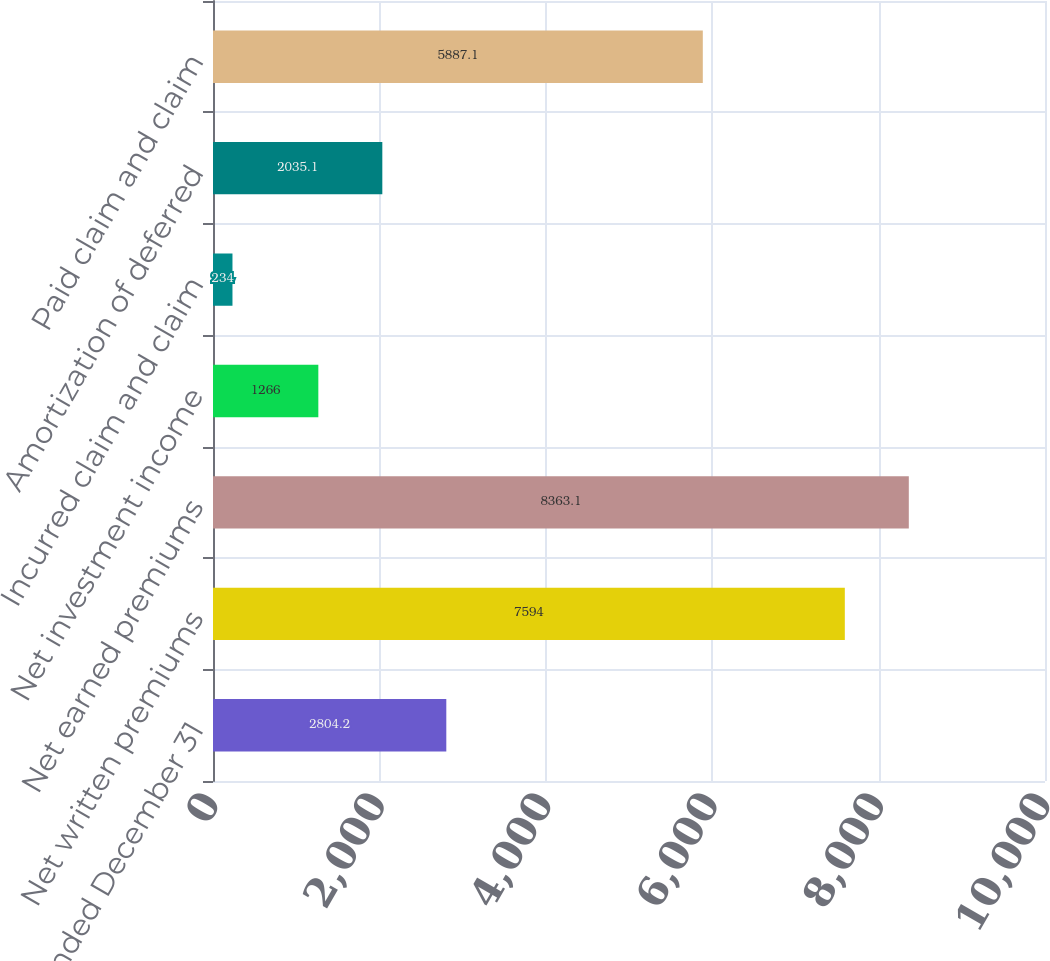Convert chart to OTSL. <chart><loc_0><loc_0><loc_500><loc_500><bar_chart><fcel>Year Ended December 31<fcel>Net written premiums<fcel>Net earned premiums<fcel>Net investment income<fcel>Incurred claim and claim<fcel>Amortization of deferred<fcel>Paid claim and claim<nl><fcel>2804.2<fcel>7594<fcel>8363.1<fcel>1266<fcel>234<fcel>2035.1<fcel>5887.1<nl></chart> 